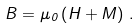Convert formula to latex. <formula><loc_0><loc_0><loc_500><loc_500>B = \mu _ { 0 } \left ( H + M \right ) \, .</formula> 